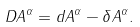<formula> <loc_0><loc_0><loc_500><loc_500>D A ^ { \alpha } = d A ^ { \alpha } - \delta A ^ { \alpha } .</formula> 